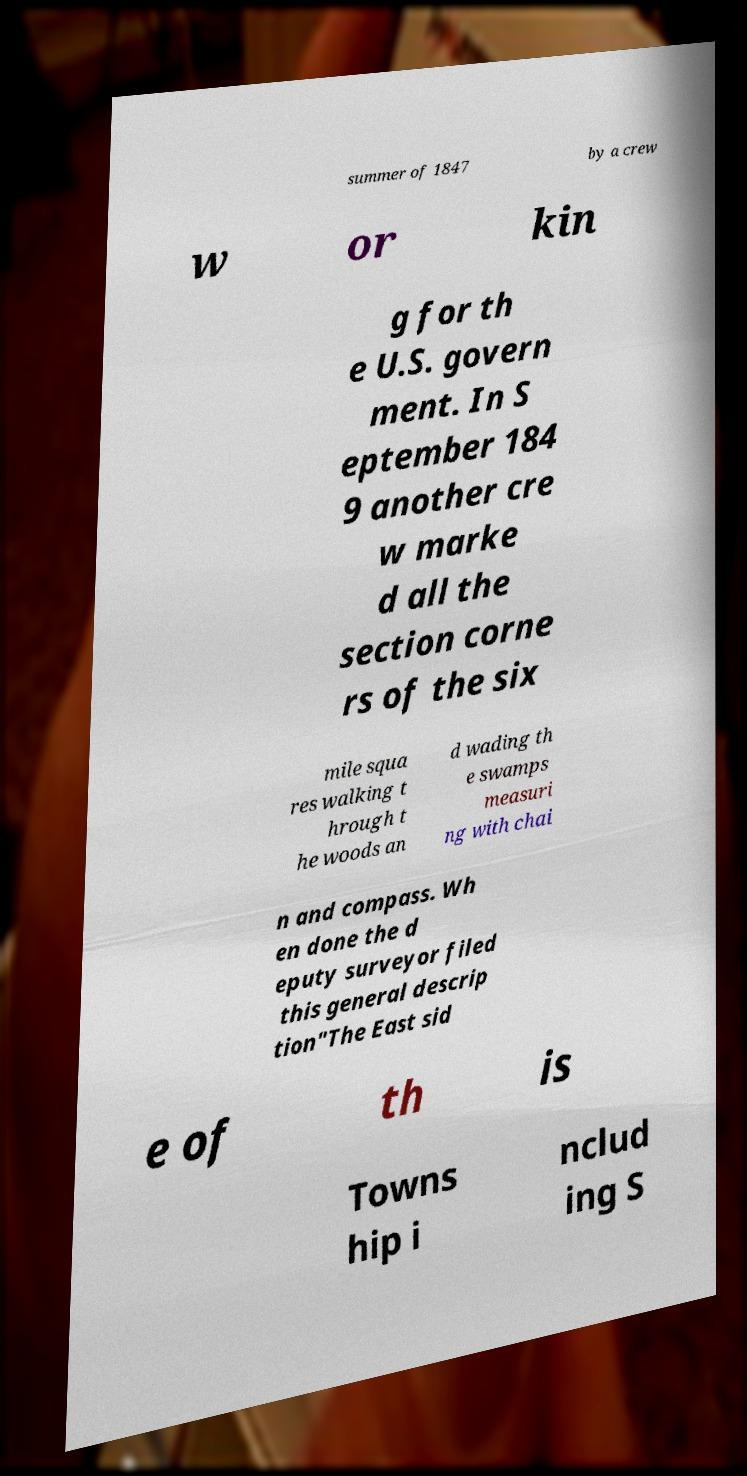Please read and relay the text visible in this image. What does it say? summer of 1847 by a crew w or kin g for th e U.S. govern ment. In S eptember 184 9 another cre w marke d all the section corne rs of the six mile squa res walking t hrough t he woods an d wading th e swamps measuri ng with chai n and compass. Wh en done the d eputy surveyor filed this general descrip tion"The East sid e of th is Towns hip i nclud ing S 